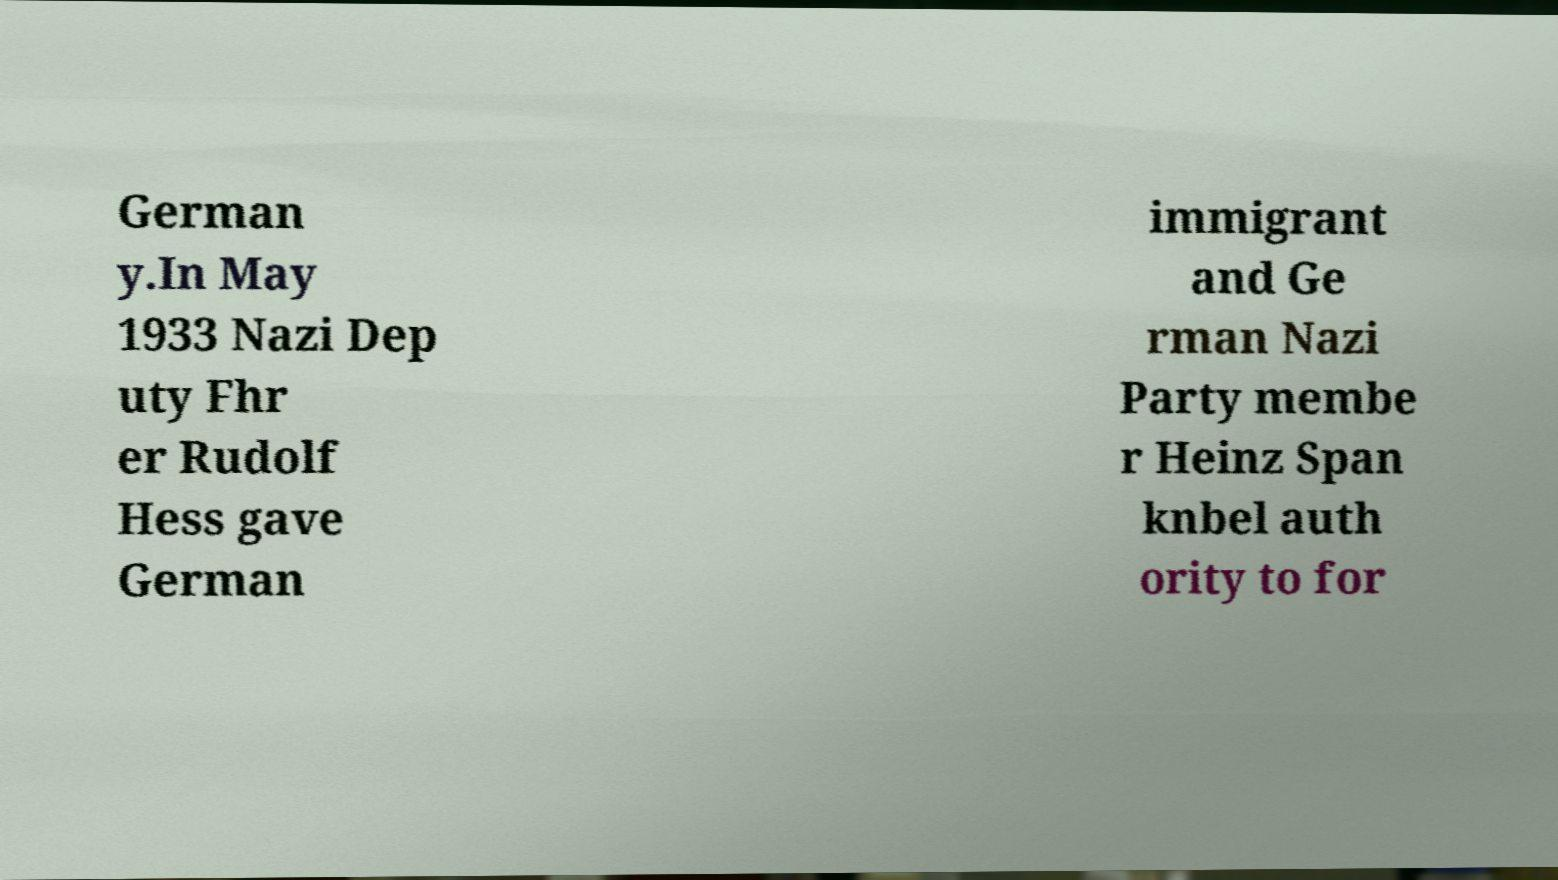Please read and relay the text visible in this image. What does it say? German y.In May 1933 Nazi Dep uty Fhr er Rudolf Hess gave German immigrant and Ge rman Nazi Party membe r Heinz Span knbel auth ority to for 